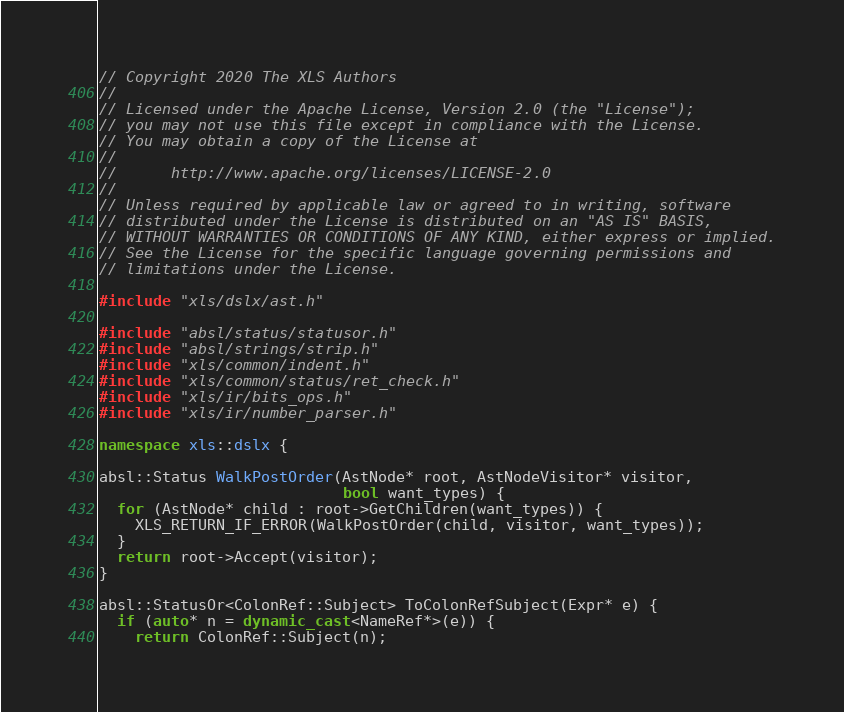Convert code to text. <code><loc_0><loc_0><loc_500><loc_500><_C++_>// Copyright 2020 The XLS Authors
//
// Licensed under the Apache License, Version 2.0 (the "License");
// you may not use this file except in compliance with the License.
// You may obtain a copy of the License at
//
//      http://www.apache.org/licenses/LICENSE-2.0
//
// Unless required by applicable law or agreed to in writing, software
// distributed under the License is distributed on an "AS IS" BASIS,
// WITHOUT WARRANTIES OR CONDITIONS OF ANY KIND, either express or implied.
// See the License for the specific language governing permissions and
// limitations under the License.

#include "xls/dslx/ast.h"

#include "absl/status/statusor.h"
#include "absl/strings/strip.h"
#include "xls/common/indent.h"
#include "xls/common/status/ret_check.h"
#include "xls/ir/bits_ops.h"
#include "xls/ir/number_parser.h"

namespace xls::dslx {

absl::Status WalkPostOrder(AstNode* root, AstNodeVisitor* visitor,
                           bool want_types) {
  for (AstNode* child : root->GetChildren(want_types)) {
    XLS_RETURN_IF_ERROR(WalkPostOrder(child, visitor, want_types));
  }
  return root->Accept(visitor);
}

absl::StatusOr<ColonRef::Subject> ToColonRefSubject(Expr* e) {
  if (auto* n = dynamic_cast<NameRef*>(e)) {
    return ColonRef::Subject(n);</code> 